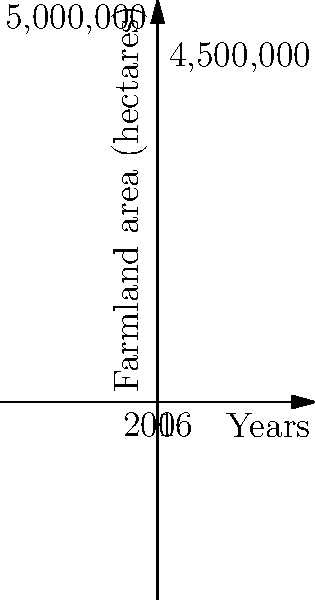The graph shows the estimated area of farmland affected by EU regulations in England from 2006 to 2016. If this trend continued, how many hectares of farmland would be affected by EU regulations in 2021, just before Brexit? To solve this problem, let's follow these steps:

1. Understand the graph:
   - The y-axis represents the farmland area in hectares.
   - The x-axis represents years, with 0 being 2006 and 10 being 2016.

2. Calculate the rate of change:
   - In 2006 (x=0), the area was 5,000,000 hectares.
   - In 2016 (x=10), the area was 4,500,000 hectares.
   - Total change = 5,000,000 - 4,500,000 = 500,000 hectares
   - Rate of change = 500,000 ÷ 10 years = 50,000 hectares per year

3. Determine the number of years from 2016 to 2021:
   2021 - 2016 = 5 years

4. Calculate the additional change from 2016 to 2021:
   50,000 hectares/year × 5 years = 250,000 hectares

5. Calculate the final area in 2021:
   4,500,000 - 250,000 = 4,250,000 hectares

Therefore, if the trend continued, the area of farmland affected by EU regulations in 2021 would be 4,250,000 hectares.
Answer: 4,250,000 hectares 